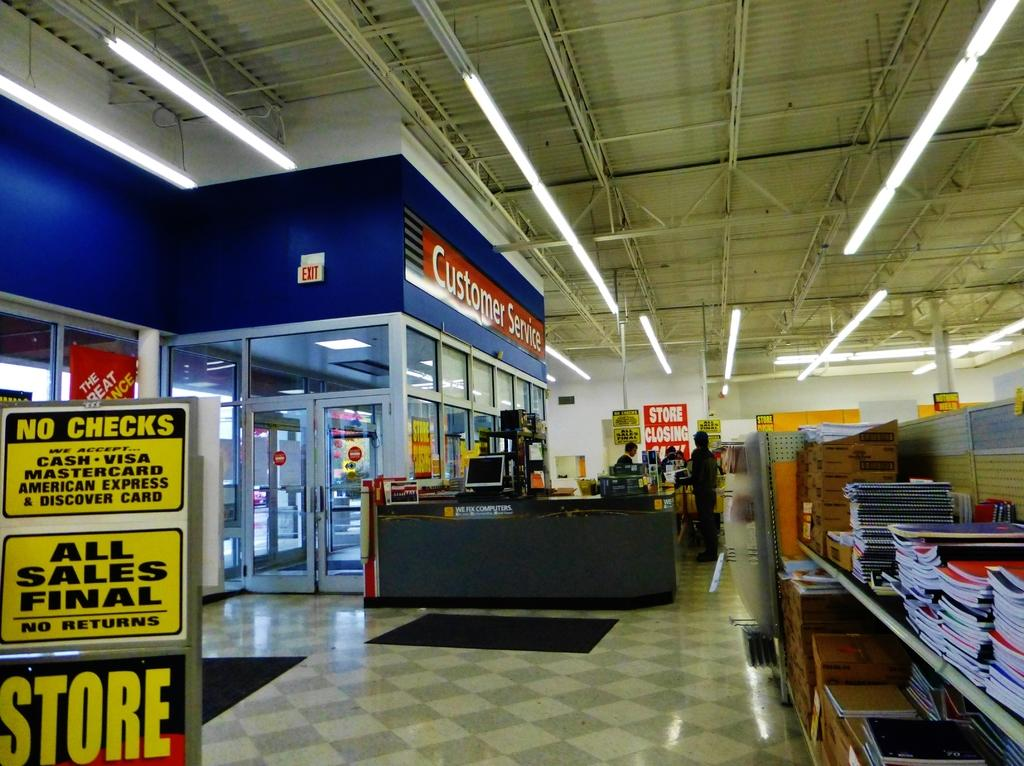<image>
Describe the image concisely. the inside of a store with a portion labeled at the top with 'customer service' 